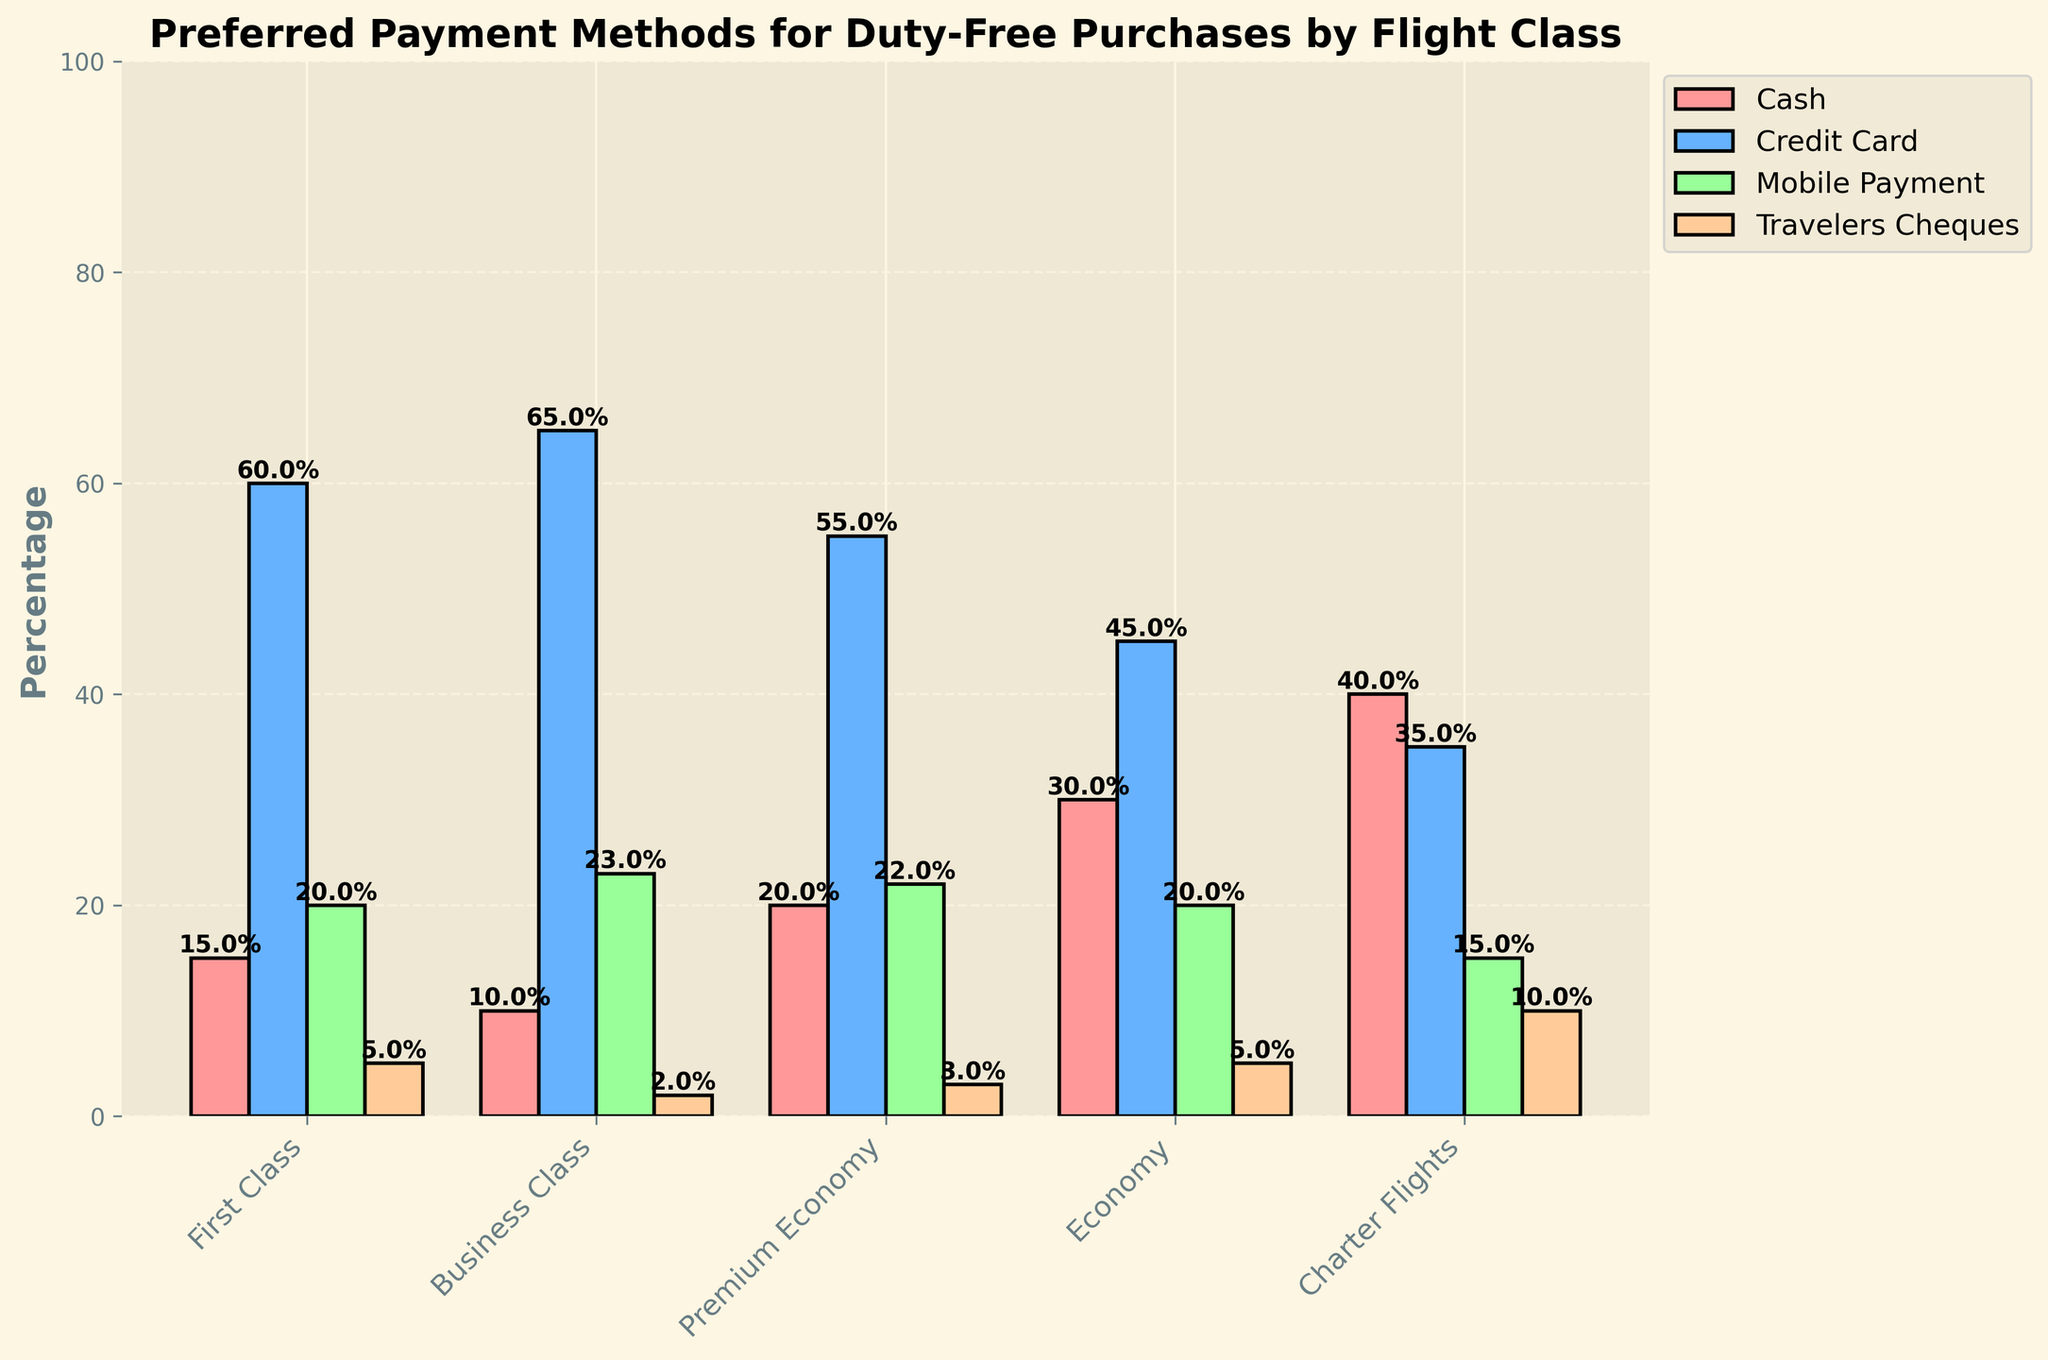What's the preferred payment method for First Class passengers? Look at the figure for the First Class category. The bar with the highest percentage represents the preferred payment method. The Credit Card bar is the highest for First Class passengers at 60%.
Answer: Credit Card In which flight class is cash the least preferred payment method? Look at the percentages for cash payments across all flight classes. Find the minimum percentage value, which is 10% in Business Class.
Answer: Business Class What is the total percentage of travelers cheques usage across all flight classes? Sum up all the percentages for travelers cheques: 5% (First Class) + 2% (Business Class) + 3% (Premium Economy) + 5% (Economy) + 10% (Charter Flights) = 25%
Answer: 25% Compare the preference for mobile payment between Business Class and Premium Economy passengers. Which class prefers it more? Look at the bars representing mobile payment for Business Class and Premium Economy. Business Class has a 23% preference while Premium Economy has a 22% preference. Therefore, Business Class prefers it more.
Answer: Business Class Which flight class shows an equal preference between cash and mobile payment methods? Check for flight classes where the bars for cash and mobile payment methods have the same height. Economy class has both cash and mobile payment at 20%.
Answer: Economy Between Economy and Charter Flights, which class uses travelers cheques more frequently? Compare the heights of the bars representing travelers cheques for both Economy and Charter Flights. Charter Flights have a higher percentage at 10% compared to 5% for Economy.
Answer: Charter Flights What is the average percentage preference for credit card payments across all flight classes? Calculate the average percentage by summing the credit card preferences and dividing by the number of classes: (60% + 65% + 55% + 45% + 35%) ÷ 5 = 52%
Answer: 52% If you combine the percentage of mobile payments and travelers cheques used in Charter Flights, what is the total percentage? Add the percentages of mobile payments and travelers cheques for Charter Flights: 15% (Mobile Payment) + 10% (Travelers Cheques) = 25%
Answer: 25% What payment method is the least preferred among First Class passengers? Look at the bars for First Class passengers and find the lowest percentage. Travelers Cheques at 5% is the least preferred method.
Answer: Travelers Cheques 